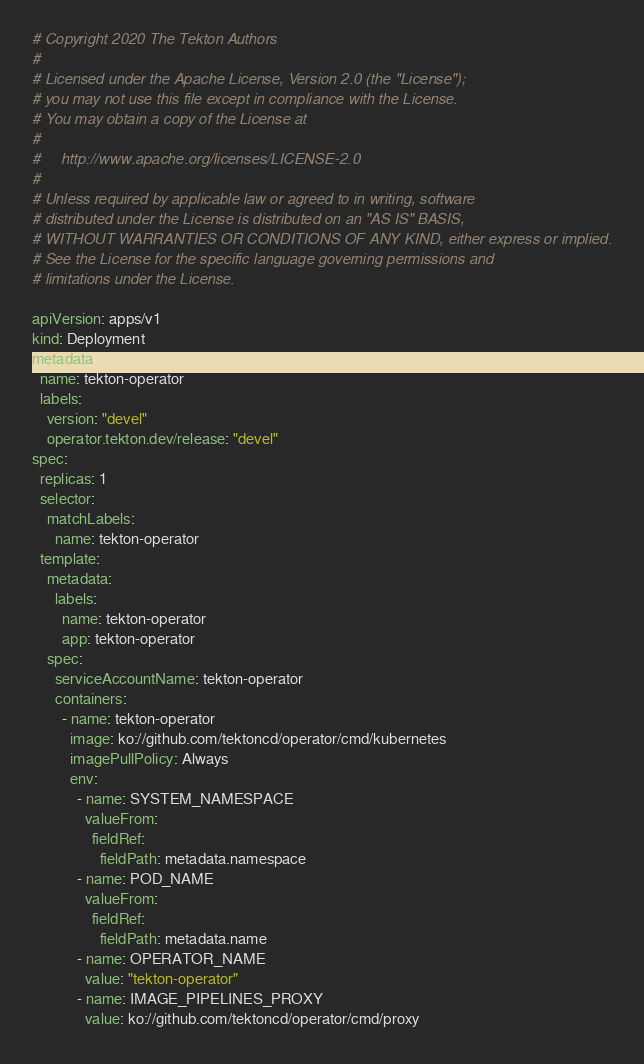Convert code to text. <code><loc_0><loc_0><loc_500><loc_500><_YAML_># Copyright 2020 The Tekton Authors
#
# Licensed under the Apache License, Version 2.0 (the "License");
# you may not use this file except in compliance with the License.
# You may obtain a copy of the License at
#
#     http://www.apache.org/licenses/LICENSE-2.0
#
# Unless required by applicable law or agreed to in writing, software
# distributed under the License is distributed on an "AS IS" BASIS,
# WITHOUT WARRANTIES OR CONDITIONS OF ANY KIND, either express or implied.
# See the License for the specific language governing permissions and
# limitations under the License.

apiVersion: apps/v1
kind: Deployment
metadata:
  name: tekton-operator
  labels:
    version: "devel"
    operator.tekton.dev/release: "devel"
spec:
  replicas: 1
  selector:
    matchLabels:
      name: tekton-operator
  template:
    metadata:
      labels:
        name: tekton-operator
        app: tekton-operator
    spec:
      serviceAccountName: tekton-operator
      containers:
        - name: tekton-operator
          image: ko://github.com/tektoncd/operator/cmd/kubernetes
          imagePullPolicy: Always
          env:
            - name: SYSTEM_NAMESPACE
              valueFrom:
                fieldRef:
                  fieldPath: metadata.namespace
            - name: POD_NAME
              valueFrom:
                fieldRef:
                  fieldPath: metadata.name
            - name: OPERATOR_NAME
              value: "tekton-operator"
            - name: IMAGE_PIPELINES_PROXY
              value: ko://github.com/tektoncd/operator/cmd/proxy
</code> 